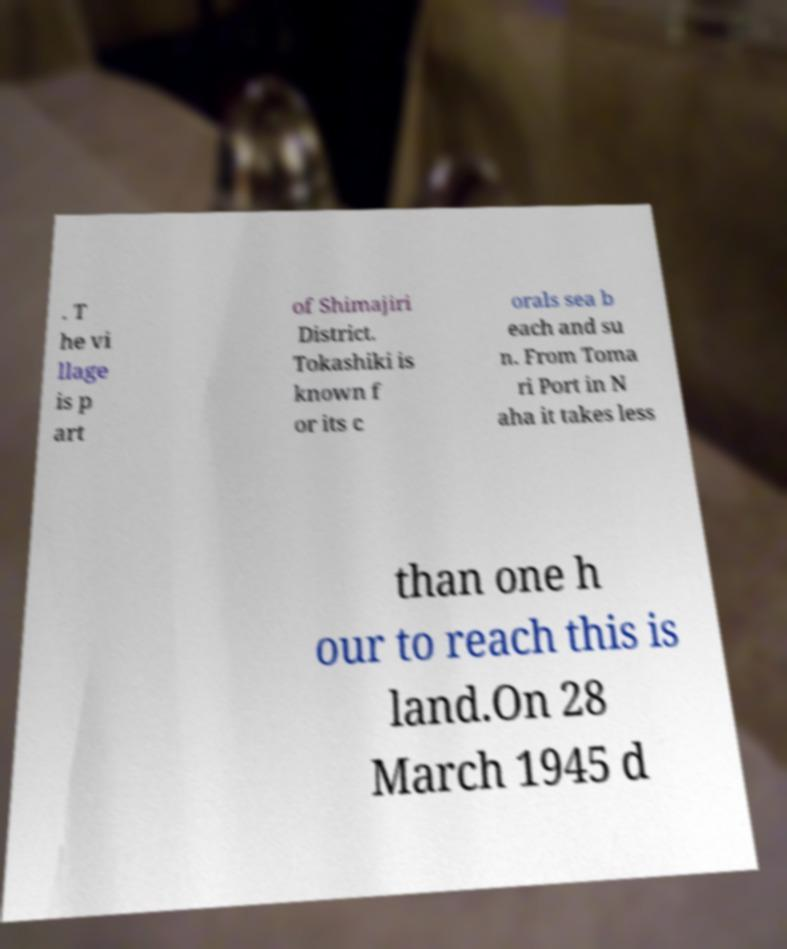Please identify and transcribe the text found in this image. . T he vi llage is p art of Shimajiri District. Tokashiki is known f or its c orals sea b each and su n. From Toma ri Port in N aha it takes less than one h our to reach this is land.On 28 March 1945 d 